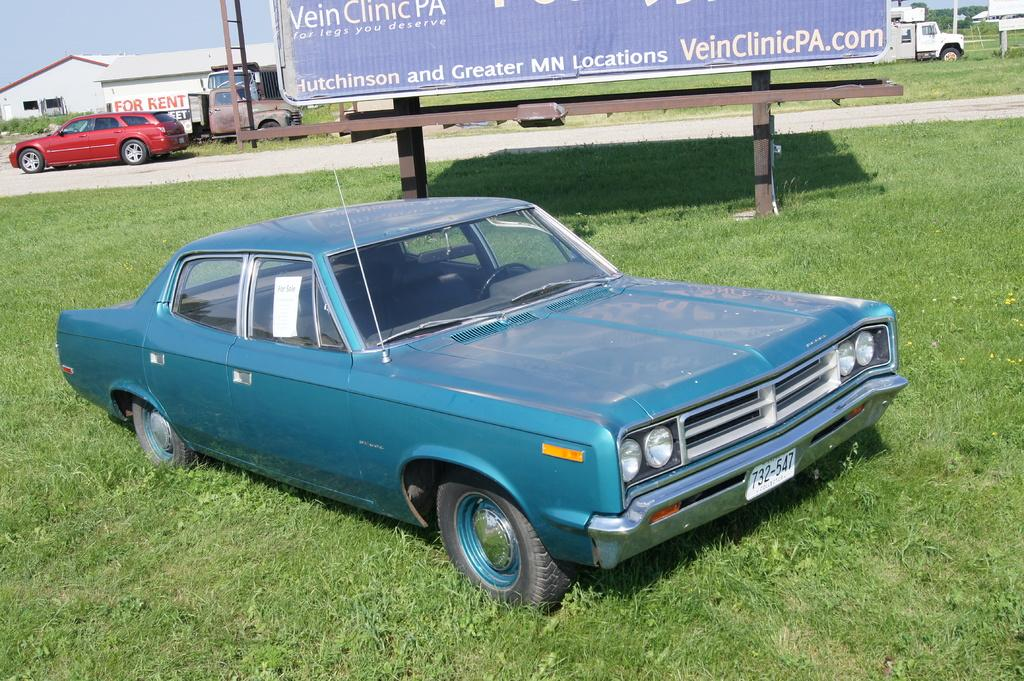What types of objects are present in the image? There are vehicles, grass, a border, plants, sheds, and the sky is visible in the background. Can you describe the landscape in the image? The image features grass, plants, and sheds, suggesting a rural or outdoor setting. What is the color of the sky in the image? The sky is visible in the background of the image, but the color is not mentioned in the facts. Are there any man-made structures in the image? Yes, there are sheds in the image. What type of scarf is draped over the vehicle in the image? There is no scarf draped over any vehicle in the image. What news headline can be seen on the sheds in the image? There is no news or headline mentioned in the image; it only features vehicles, grass, a border, plants, sheds, and the sky. 